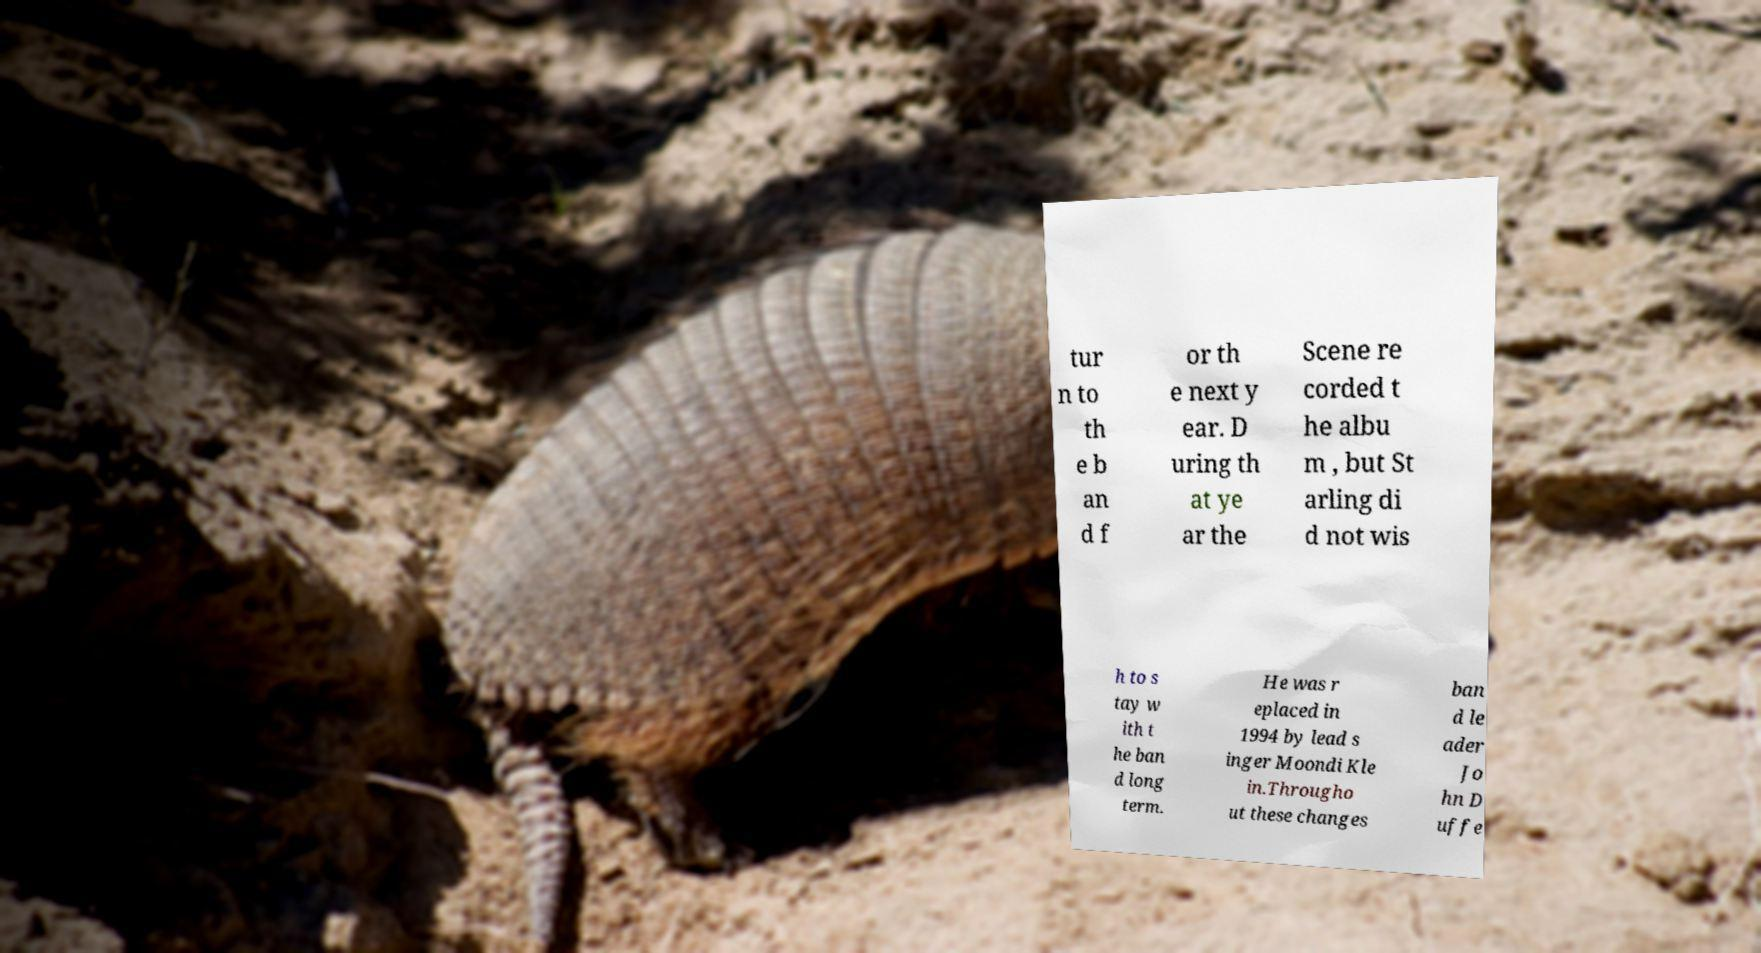Can you read and provide the text displayed in the image?This photo seems to have some interesting text. Can you extract and type it out for me? tur n to th e b an d f or th e next y ear. D uring th at ye ar the Scene re corded t he albu m , but St arling di d not wis h to s tay w ith t he ban d long term. He was r eplaced in 1994 by lead s inger Moondi Kle in.Througho ut these changes ban d le ader Jo hn D uffe 